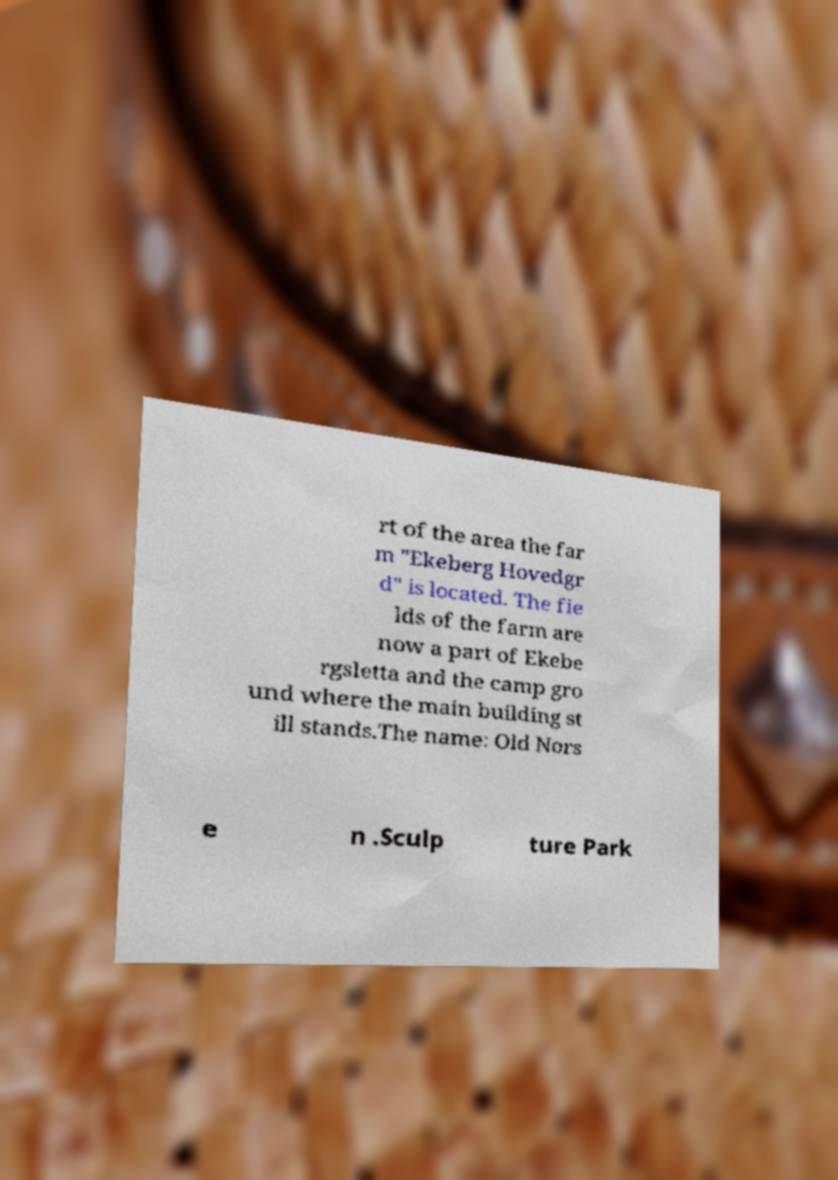I need the written content from this picture converted into text. Can you do that? rt of the area the far m "Ekeberg Hovedgr d" is located. The fie lds of the farm are now a part of Ekebe rgsletta and the camp gro und where the main building st ill stands.The name: Old Nors e n .Sculp ture Park 